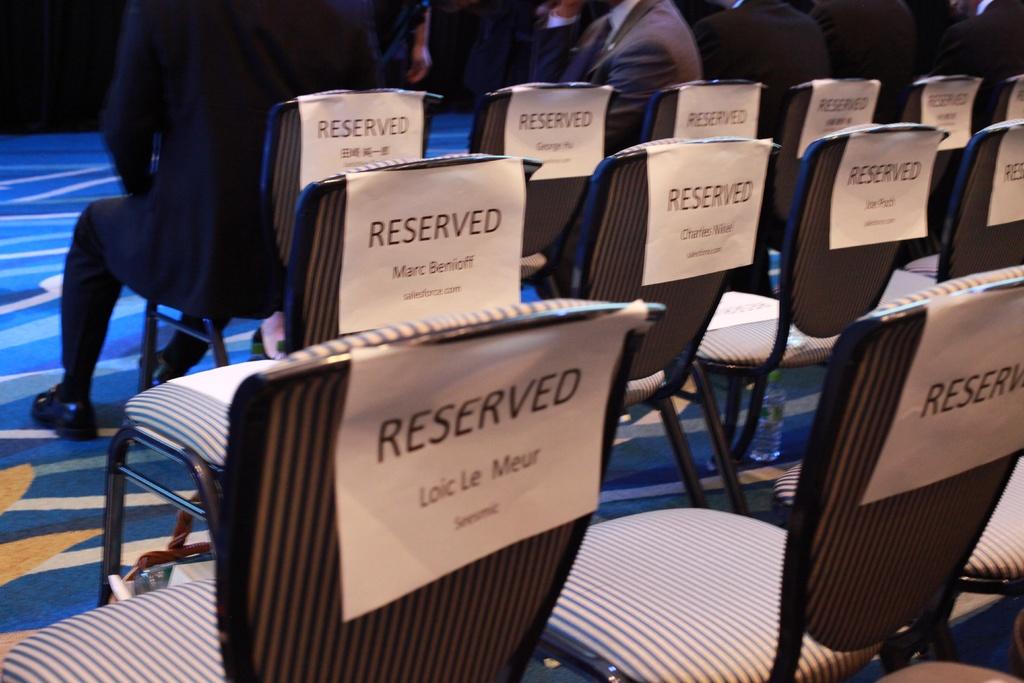Who is the front left seat reserved for?
Provide a succinct answer. Loic le meur. 